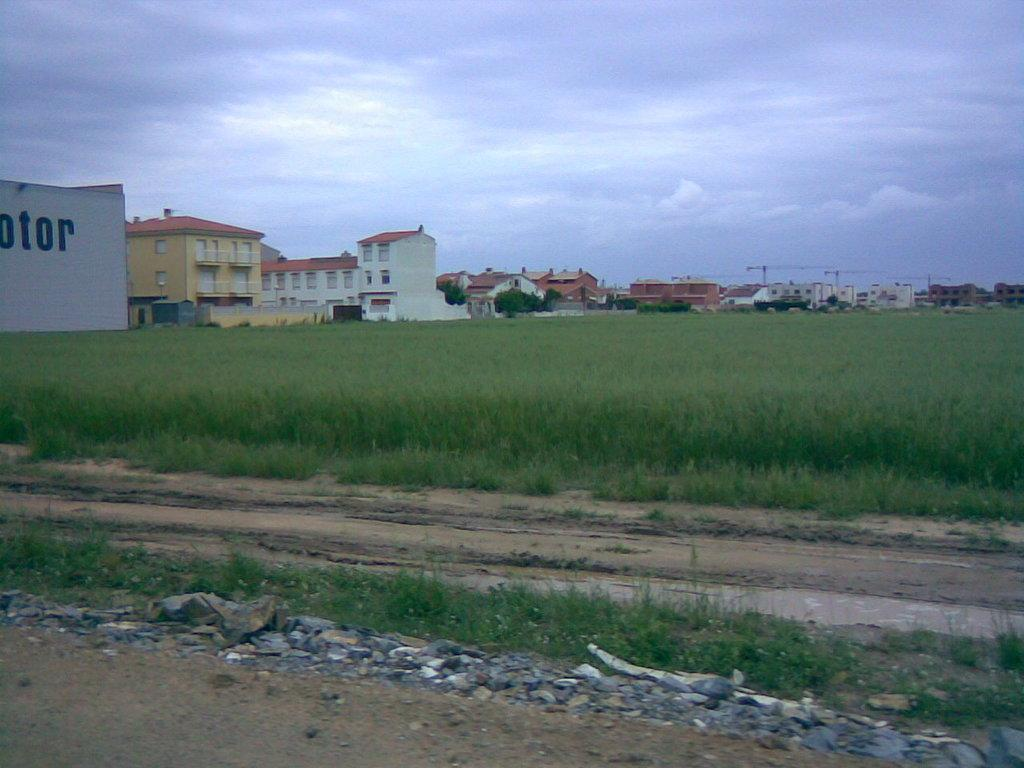What type of structures can be seen in the image? There are buildings with windows in the image. What can be seen in the background of the image? Tower cranes are visible in the background of the image. What type of terrain is present in the image? There are rocks and fields in the image. What is visible above the structures and terrain in the image? The sky is visible in the image. What type of straw is being used to write the verse on the quarter in the image? There is no straw, verse, or quarter present in the image. 